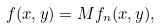<formula> <loc_0><loc_0><loc_500><loc_500>f ( x , y ) = M f _ { n } ( x , y ) ,</formula> 